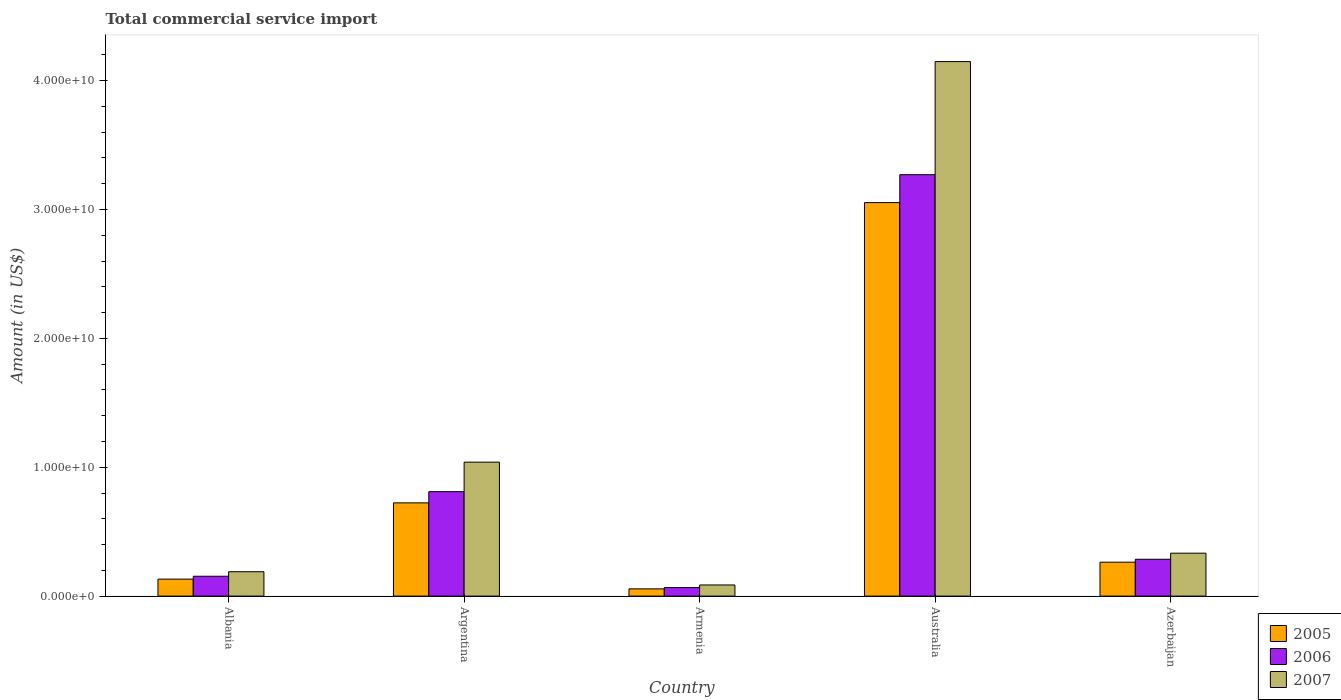How many groups of bars are there?
Ensure brevity in your answer.  5. Are the number of bars on each tick of the X-axis equal?
Offer a very short reply. Yes. What is the label of the 3rd group of bars from the left?
Ensure brevity in your answer.  Armenia. In how many cases, is the number of bars for a given country not equal to the number of legend labels?
Offer a terse response. 0. What is the total commercial service import in 2007 in Australia?
Make the answer very short. 4.15e+1. Across all countries, what is the maximum total commercial service import in 2005?
Provide a succinct answer. 3.05e+1. Across all countries, what is the minimum total commercial service import in 2006?
Your answer should be compact. 6.62e+08. In which country was the total commercial service import in 2007 minimum?
Your answer should be compact. Armenia. What is the total total commercial service import in 2007 in the graph?
Your response must be concise. 5.80e+1. What is the difference between the total commercial service import in 2006 in Albania and that in Armenia?
Offer a terse response. 8.79e+08. What is the difference between the total commercial service import in 2007 in Armenia and the total commercial service import in 2006 in Argentina?
Make the answer very short. -7.24e+09. What is the average total commercial service import in 2005 per country?
Ensure brevity in your answer.  8.46e+09. What is the difference between the total commercial service import of/in 2007 and total commercial service import of/in 2005 in Australia?
Provide a succinct answer. 1.09e+1. What is the ratio of the total commercial service import in 2007 in Albania to that in Argentina?
Give a very brief answer. 0.18. Is the difference between the total commercial service import in 2007 in Albania and Argentina greater than the difference between the total commercial service import in 2005 in Albania and Argentina?
Provide a short and direct response. No. What is the difference between the highest and the second highest total commercial service import in 2005?
Your answer should be very brief. 2.33e+1. What is the difference between the highest and the lowest total commercial service import in 2005?
Your answer should be compact. 3.00e+1. Is the sum of the total commercial service import in 2005 in Argentina and Armenia greater than the maximum total commercial service import in 2007 across all countries?
Make the answer very short. No. What does the 1st bar from the right in Armenia represents?
Offer a terse response. 2007. Is it the case that in every country, the sum of the total commercial service import in 2007 and total commercial service import in 2005 is greater than the total commercial service import in 2006?
Provide a short and direct response. Yes. How many bars are there?
Ensure brevity in your answer.  15. How many countries are there in the graph?
Offer a terse response. 5. Does the graph contain grids?
Your response must be concise. No. How are the legend labels stacked?
Make the answer very short. Vertical. What is the title of the graph?
Provide a succinct answer. Total commercial service import. What is the label or title of the X-axis?
Make the answer very short. Country. What is the label or title of the Y-axis?
Provide a succinct answer. Amount (in US$). What is the Amount (in US$) of 2005 in Albania?
Provide a succinct answer. 1.32e+09. What is the Amount (in US$) in 2006 in Albania?
Your answer should be compact. 1.54e+09. What is the Amount (in US$) in 2007 in Albania?
Make the answer very short. 1.89e+09. What is the Amount (in US$) of 2005 in Argentina?
Offer a very short reply. 7.24e+09. What is the Amount (in US$) of 2006 in Argentina?
Give a very brief answer. 8.10e+09. What is the Amount (in US$) of 2007 in Argentina?
Make the answer very short. 1.04e+1. What is the Amount (in US$) in 2005 in Armenia?
Keep it short and to the point. 5.61e+08. What is the Amount (in US$) in 2006 in Armenia?
Ensure brevity in your answer.  6.62e+08. What is the Amount (in US$) in 2007 in Armenia?
Make the answer very short. 8.64e+08. What is the Amount (in US$) in 2005 in Australia?
Give a very brief answer. 3.05e+1. What is the Amount (in US$) in 2006 in Australia?
Offer a very short reply. 3.27e+1. What is the Amount (in US$) of 2007 in Australia?
Provide a succinct answer. 4.15e+1. What is the Amount (in US$) of 2005 in Azerbaijan?
Keep it short and to the point. 2.63e+09. What is the Amount (in US$) of 2006 in Azerbaijan?
Provide a short and direct response. 2.86e+09. What is the Amount (in US$) in 2007 in Azerbaijan?
Your response must be concise. 3.33e+09. Across all countries, what is the maximum Amount (in US$) of 2005?
Make the answer very short. 3.05e+1. Across all countries, what is the maximum Amount (in US$) in 2006?
Provide a succinct answer. 3.27e+1. Across all countries, what is the maximum Amount (in US$) in 2007?
Provide a succinct answer. 4.15e+1. Across all countries, what is the minimum Amount (in US$) of 2005?
Provide a succinct answer. 5.61e+08. Across all countries, what is the minimum Amount (in US$) of 2006?
Give a very brief answer. 6.62e+08. Across all countries, what is the minimum Amount (in US$) in 2007?
Keep it short and to the point. 8.64e+08. What is the total Amount (in US$) in 2005 in the graph?
Provide a succinct answer. 4.23e+1. What is the total Amount (in US$) of 2006 in the graph?
Give a very brief answer. 4.59e+1. What is the total Amount (in US$) in 2007 in the graph?
Keep it short and to the point. 5.80e+1. What is the difference between the Amount (in US$) in 2005 in Albania and that in Argentina?
Give a very brief answer. -5.92e+09. What is the difference between the Amount (in US$) of 2006 in Albania and that in Argentina?
Provide a succinct answer. -6.56e+09. What is the difference between the Amount (in US$) of 2007 in Albania and that in Argentina?
Your answer should be very brief. -8.50e+09. What is the difference between the Amount (in US$) in 2005 in Albania and that in Armenia?
Ensure brevity in your answer.  7.56e+08. What is the difference between the Amount (in US$) of 2006 in Albania and that in Armenia?
Your response must be concise. 8.79e+08. What is the difference between the Amount (in US$) in 2007 in Albania and that in Armenia?
Your answer should be very brief. 1.03e+09. What is the difference between the Amount (in US$) of 2005 in Albania and that in Australia?
Provide a short and direct response. -2.92e+1. What is the difference between the Amount (in US$) of 2006 in Albania and that in Australia?
Your response must be concise. -3.12e+1. What is the difference between the Amount (in US$) of 2007 in Albania and that in Australia?
Ensure brevity in your answer.  -3.96e+1. What is the difference between the Amount (in US$) of 2005 in Albania and that in Azerbaijan?
Ensure brevity in your answer.  -1.31e+09. What is the difference between the Amount (in US$) of 2006 in Albania and that in Azerbaijan?
Give a very brief answer. -1.32e+09. What is the difference between the Amount (in US$) of 2007 in Albania and that in Azerbaijan?
Offer a very short reply. -1.44e+09. What is the difference between the Amount (in US$) in 2005 in Argentina and that in Armenia?
Keep it short and to the point. 6.67e+09. What is the difference between the Amount (in US$) in 2006 in Argentina and that in Armenia?
Provide a short and direct response. 7.44e+09. What is the difference between the Amount (in US$) in 2007 in Argentina and that in Armenia?
Keep it short and to the point. 9.53e+09. What is the difference between the Amount (in US$) of 2005 in Argentina and that in Australia?
Keep it short and to the point. -2.33e+1. What is the difference between the Amount (in US$) of 2006 in Argentina and that in Australia?
Keep it short and to the point. -2.46e+1. What is the difference between the Amount (in US$) of 2007 in Argentina and that in Australia?
Ensure brevity in your answer.  -3.11e+1. What is the difference between the Amount (in US$) of 2005 in Argentina and that in Azerbaijan?
Provide a succinct answer. 4.60e+09. What is the difference between the Amount (in US$) in 2006 in Argentina and that in Azerbaijan?
Your response must be concise. 5.25e+09. What is the difference between the Amount (in US$) in 2007 in Argentina and that in Azerbaijan?
Provide a short and direct response. 7.06e+09. What is the difference between the Amount (in US$) in 2005 in Armenia and that in Australia?
Offer a terse response. -3.00e+1. What is the difference between the Amount (in US$) of 2006 in Armenia and that in Australia?
Provide a short and direct response. -3.20e+1. What is the difference between the Amount (in US$) in 2007 in Armenia and that in Australia?
Your answer should be compact. -4.06e+1. What is the difference between the Amount (in US$) of 2005 in Armenia and that in Azerbaijan?
Ensure brevity in your answer.  -2.07e+09. What is the difference between the Amount (in US$) in 2006 in Armenia and that in Azerbaijan?
Your response must be concise. -2.20e+09. What is the difference between the Amount (in US$) of 2007 in Armenia and that in Azerbaijan?
Offer a terse response. -2.47e+09. What is the difference between the Amount (in US$) in 2005 in Australia and that in Azerbaijan?
Your answer should be compact. 2.79e+1. What is the difference between the Amount (in US$) of 2006 in Australia and that in Azerbaijan?
Give a very brief answer. 2.98e+1. What is the difference between the Amount (in US$) in 2007 in Australia and that in Azerbaijan?
Give a very brief answer. 3.81e+1. What is the difference between the Amount (in US$) of 2005 in Albania and the Amount (in US$) of 2006 in Argentina?
Make the answer very short. -6.79e+09. What is the difference between the Amount (in US$) in 2005 in Albania and the Amount (in US$) in 2007 in Argentina?
Make the answer very short. -9.08e+09. What is the difference between the Amount (in US$) of 2006 in Albania and the Amount (in US$) of 2007 in Argentina?
Keep it short and to the point. -8.85e+09. What is the difference between the Amount (in US$) in 2005 in Albania and the Amount (in US$) in 2006 in Armenia?
Offer a very short reply. 6.55e+08. What is the difference between the Amount (in US$) of 2005 in Albania and the Amount (in US$) of 2007 in Armenia?
Provide a succinct answer. 4.53e+08. What is the difference between the Amount (in US$) in 2006 in Albania and the Amount (in US$) in 2007 in Armenia?
Your answer should be compact. 6.76e+08. What is the difference between the Amount (in US$) of 2005 in Albania and the Amount (in US$) of 2006 in Australia?
Make the answer very short. -3.14e+1. What is the difference between the Amount (in US$) of 2005 in Albania and the Amount (in US$) of 2007 in Australia?
Offer a very short reply. -4.02e+1. What is the difference between the Amount (in US$) in 2006 in Albania and the Amount (in US$) in 2007 in Australia?
Provide a succinct answer. -3.99e+1. What is the difference between the Amount (in US$) in 2005 in Albania and the Amount (in US$) in 2006 in Azerbaijan?
Ensure brevity in your answer.  -1.54e+09. What is the difference between the Amount (in US$) in 2005 in Albania and the Amount (in US$) in 2007 in Azerbaijan?
Make the answer very short. -2.01e+09. What is the difference between the Amount (in US$) in 2006 in Albania and the Amount (in US$) in 2007 in Azerbaijan?
Provide a short and direct response. -1.79e+09. What is the difference between the Amount (in US$) in 2005 in Argentina and the Amount (in US$) in 2006 in Armenia?
Make the answer very short. 6.57e+09. What is the difference between the Amount (in US$) of 2005 in Argentina and the Amount (in US$) of 2007 in Armenia?
Keep it short and to the point. 6.37e+09. What is the difference between the Amount (in US$) in 2006 in Argentina and the Amount (in US$) in 2007 in Armenia?
Your answer should be compact. 7.24e+09. What is the difference between the Amount (in US$) of 2005 in Argentina and the Amount (in US$) of 2006 in Australia?
Give a very brief answer. -2.55e+1. What is the difference between the Amount (in US$) in 2005 in Argentina and the Amount (in US$) in 2007 in Australia?
Your answer should be very brief. -3.42e+1. What is the difference between the Amount (in US$) of 2006 in Argentina and the Amount (in US$) of 2007 in Australia?
Ensure brevity in your answer.  -3.34e+1. What is the difference between the Amount (in US$) in 2005 in Argentina and the Amount (in US$) in 2006 in Azerbaijan?
Make the answer very short. 4.38e+09. What is the difference between the Amount (in US$) of 2005 in Argentina and the Amount (in US$) of 2007 in Azerbaijan?
Provide a succinct answer. 3.90e+09. What is the difference between the Amount (in US$) in 2006 in Argentina and the Amount (in US$) in 2007 in Azerbaijan?
Provide a succinct answer. 4.77e+09. What is the difference between the Amount (in US$) of 2005 in Armenia and the Amount (in US$) of 2006 in Australia?
Give a very brief answer. -3.21e+1. What is the difference between the Amount (in US$) of 2005 in Armenia and the Amount (in US$) of 2007 in Australia?
Your answer should be very brief. -4.09e+1. What is the difference between the Amount (in US$) in 2006 in Armenia and the Amount (in US$) in 2007 in Australia?
Make the answer very short. -4.08e+1. What is the difference between the Amount (in US$) of 2005 in Armenia and the Amount (in US$) of 2006 in Azerbaijan?
Give a very brief answer. -2.30e+09. What is the difference between the Amount (in US$) of 2005 in Armenia and the Amount (in US$) of 2007 in Azerbaijan?
Provide a succinct answer. -2.77e+09. What is the difference between the Amount (in US$) in 2006 in Armenia and the Amount (in US$) in 2007 in Azerbaijan?
Keep it short and to the point. -2.67e+09. What is the difference between the Amount (in US$) of 2005 in Australia and the Amount (in US$) of 2006 in Azerbaijan?
Your answer should be very brief. 2.77e+1. What is the difference between the Amount (in US$) in 2005 in Australia and the Amount (in US$) in 2007 in Azerbaijan?
Make the answer very short. 2.72e+1. What is the difference between the Amount (in US$) in 2006 in Australia and the Amount (in US$) in 2007 in Azerbaijan?
Offer a very short reply. 2.94e+1. What is the average Amount (in US$) in 2005 per country?
Make the answer very short. 8.46e+09. What is the average Amount (in US$) of 2006 per country?
Your response must be concise. 9.17e+09. What is the average Amount (in US$) in 2007 per country?
Make the answer very short. 1.16e+1. What is the difference between the Amount (in US$) of 2005 and Amount (in US$) of 2006 in Albania?
Your response must be concise. -2.23e+08. What is the difference between the Amount (in US$) of 2005 and Amount (in US$) of 2007 in Albania?
Offer a terse response. -5.74e+08. What is the difference between the Amount (in US$) of 2006 and Amount (in US$) of 2007 in Albania?
Give a very brief answer. -3.51e+08. What is the difference between the Amount (in US$) in 2005 and Amount (in US$) in 2006 in Argentina?
Your answer should be compact. -8.69e+08. What is the difference between the Amount (in US$) in 2005 and Amount (in US$) in 2007 in Argentina?
Give a very brief answer. -3.16e+09. What is the difference between the Amount (in US$) of 2006 and Amount (in US$) of 2007 in Argentina?
Keep it short and to the point. -2.29e+09. What is the difference between the Amount (in US$) in 2005 and Amount (in US$) in 2006 in Armenia?
Your response must be concise. -1.01e+08. What is the difference between the Amount (in US$) in 2005 and Amount (in US$) in 2007 in Armenia?
Offer a very short reply. -3.03e+08. What is the difference between the Amount (in US$) in 2006 and Amount (in US$) in 2007 in Armenia?
Provide a succinct answer. -2.02e+08. What is the difference between the Amount (in US$) in 2005 and Amount (in US$) in 2006 in Australia?
Your answer should be very brief. -2.17e+09. What is the difference between the Amount (in US$) of 2005 and Amount (in US$) of 2007 in Australia?
Your answer should be very brief. -1.09e+1. What is the difference between the Amount (in US$) of 2006 and Amount (in US$) of 2007 in Australia?
Offer a terse response. -8.78e+09. What is the difference between the Amount (in US$) of 2005 and Amount (in US$) of 2006 in Azerbaijan?
Your answer should be very brief. -2.28e+08. What is the difference between the Amount (in US$) of 2005 and Amount (in US$) of 2007 in Azerbaijan?
Offer a terse response. -7.00e+08. What is the difference between the Amount (in US$) in 2006 and Amount (in US$) in 2007 in Azerbaijan?
Your answer should be very brief. -4.72e+08. What is the ratio of the Amount (in US$) in 2005 in Albania to that in Argentina?
Provide a short and direct response. 0.18. What is the ratio of the Amount (in US$) of 2006 in Albania to that in Argentina?
Ensure brevity in your answer.  0.19. What is the ratio of the Amount (in US$) in 2007 in Albania to that in Argentina?
Your answer should be compact. 0.18. What is the ratio of the Amount (in US$) in 2005 in Albania to that in Armenia?
Provide a succinct answer. 2.35. What is the ratio of the Amount (in US$) in 2006 in Albania to that in Armenia?
Provide a succinct answer. 2.33. What is the ratio of the Amount (in US$) in 2007 in Albania to that in Armenia?
Keep it short and to the point. 2.19. What is the ratio of the Amount (in US$) in 2005 in Albania to that in Australia?
Ensure brevity in your answer.  0.04. What is the ratio of the Amount (in US$) of 2006 in Albania to that in Australia?
Make the answer very short. 0.05. What is the ratio of the Amount (in US$) in 2007 in Albania to that in Australia?
Provide a succinct answer. 0.05. What is the ratio of the Amount (in US$) in 2005 in Albania to that in Azerbaijan?
Make the answer very short. 0.5. What is the ratio of the Amount (in US$) of 2006 in Albania to that in Azerbaijan?
Give a very brief answer. 0.54. What is the ratio of the Amount (in US$) in 2007 in Albania to that in Azerbaijan?
Offer a terse response. 0.57. What is the ratio of the Amount (in US$) of 2005 in Argentina to that in Armenia?
Make the answer very short. 12.89. What is the ratio of the Amount (in US$) of 2006 in Argentina to that in Armenia?
Provide a succinct answer. 12.24. What is the ratio of the Amount (in US$) of 2007 in Argentina to that in Armenia?
Your answer should be very brief. 12.03. What is the ratio of the Amount (in US$) in 2005 in Argentina to that in Australia?
Make the answer very short. 0.24. What is the ratio of the Amount (in US$) of 2006 in Argentina to that in Australia?
Offer a very short reply. 0.25. What is the ratio of the Amount (in US$) in 2007 in Argentina to that in Australia?
Your response must be concise. 0.25. What is the ratio of the Amount (in US$) in 2005 in Argentina to that in Azerbaijan?
Your answer should be very brief. 2.75. What is the ratio of the Amount (in US$) of 2006 in Argentina to that in Azerbaijan?
Provide a short and direct response. 2.83. What is the ratio of the Amount (in US$) of 2007 in Argentina to that in Azerbaijan?
Provide a short and direct response. 3.12. What is the ratio of the Amount (in US$) in 2005 in Armenia to that in Australia?
Give a very brief answer. 0.02. What is the ratio of the Amount (in US$) of 2006 in Armenia to that in Australia?
Offer a terse response. 0.02. What is the ratio of the Amount (in US$) in 2007 in Armenia to that in Australia?
Your response must be concise. 0.02. What is the ratio of the Amount (in US$) in 2005 in Armenia to that in Azerbaijan?
Make the answer very short. 0.21. What is the ratio of the Amount (in US$) of 2006 in Armenia to that in Azerbaijan?
Offer a terse response. 0.23. What is the ratio of the Amount (in US$) of 2007 in Armenia to that in Azerbaijan?
Provide a short and direct response. 0.26. What is the ratio of the Amount (in US$) of 2005 in Australia to that in Azerbaijan?
Your answer should be very brief. 11.61. What is the ratio of the Amount (in US$) of 2006 in Australia to that in Azerbaijan?
Provide a succinct answer. 11.44. What is the ratio of the Amount (in US$) in 2007 in Australia to that in Azerbaijan?
Give a very brief answer. 12.45. What is the difference between the highest and the second highest Amount (in US$) in 2005?
Provide a succinct answer. 2.33e+1. What is the difference between the highest and the second highest Amount (in US$) of 2006?
Offer a terse response. 2.46e+1. What is the difference between the highest and the second highest Amount (in US$) of 2007?
Provide a succinct answer. 3.11e+1. What is the difference between the highest and the lowest Amount (in US$) of 2005?
Provide a short and direct response. 3.00e+1. What is the difference between the highest and the lowest Amount (in US$) of 2006?
Offer a very short reply. 3.20e+1. What is the difference between the highest and the lowest Amount (in US$) of 2007?
Make the answer very short. 4.06e+1. 